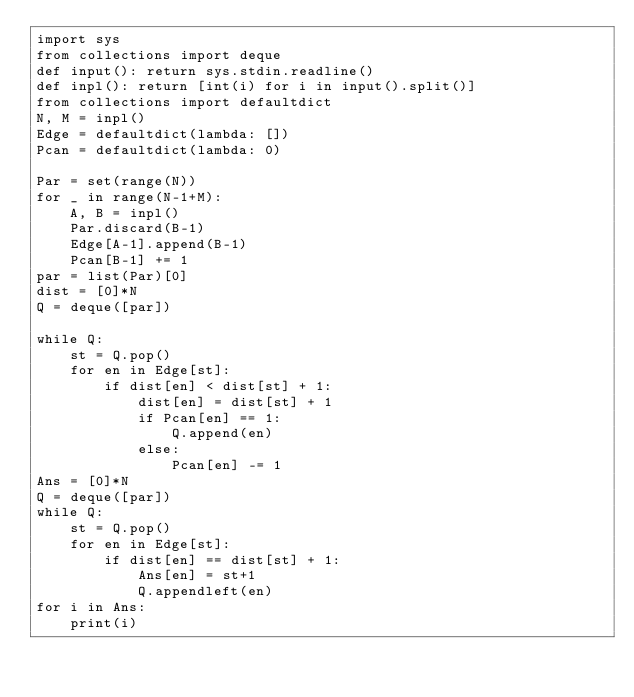Convert code to text. <code><loc_0><loc_0><loc_500><loc_500><_Python_>import sys
from collections import deque
def input(): return sys.stdin.readline()
def inpl(): return [int(i) for i in input().split()]
from collections import defaultdict
N, M = inpl()
Edge = defaultdict(lambda: [])
Pcan = defaultdict(lambda: 0)

Par = set(range(N)) 
for _ in range(N-1+M):
    A, B = inpl()
    Par.discard(B-1)
    Edge[A-1].append(B-1)
    Pcan[B-1] += 1
par = list(Par)[0]
dist = [0]*N
Q = deque([par])

while Q:
    st = Q.pop()
    for en in Edge[st]:
        if dist[en] < dist[st] + 1:
            dist[en] = dist[st] + 1
            if Pcan[en] == 1:
                Q.append(en)
            else:
                Pcan[en] -= 1
Ans = [0]*N
Q = deque([par]) 
while Q:
    st = Q.pop()
    for en in Edge[st]:
        if dist[en] == dist[st] + 1:
            Ans[en] = st+1
            Q.appendleft(en)
for i in Ans:
    print(i)    
</code> 